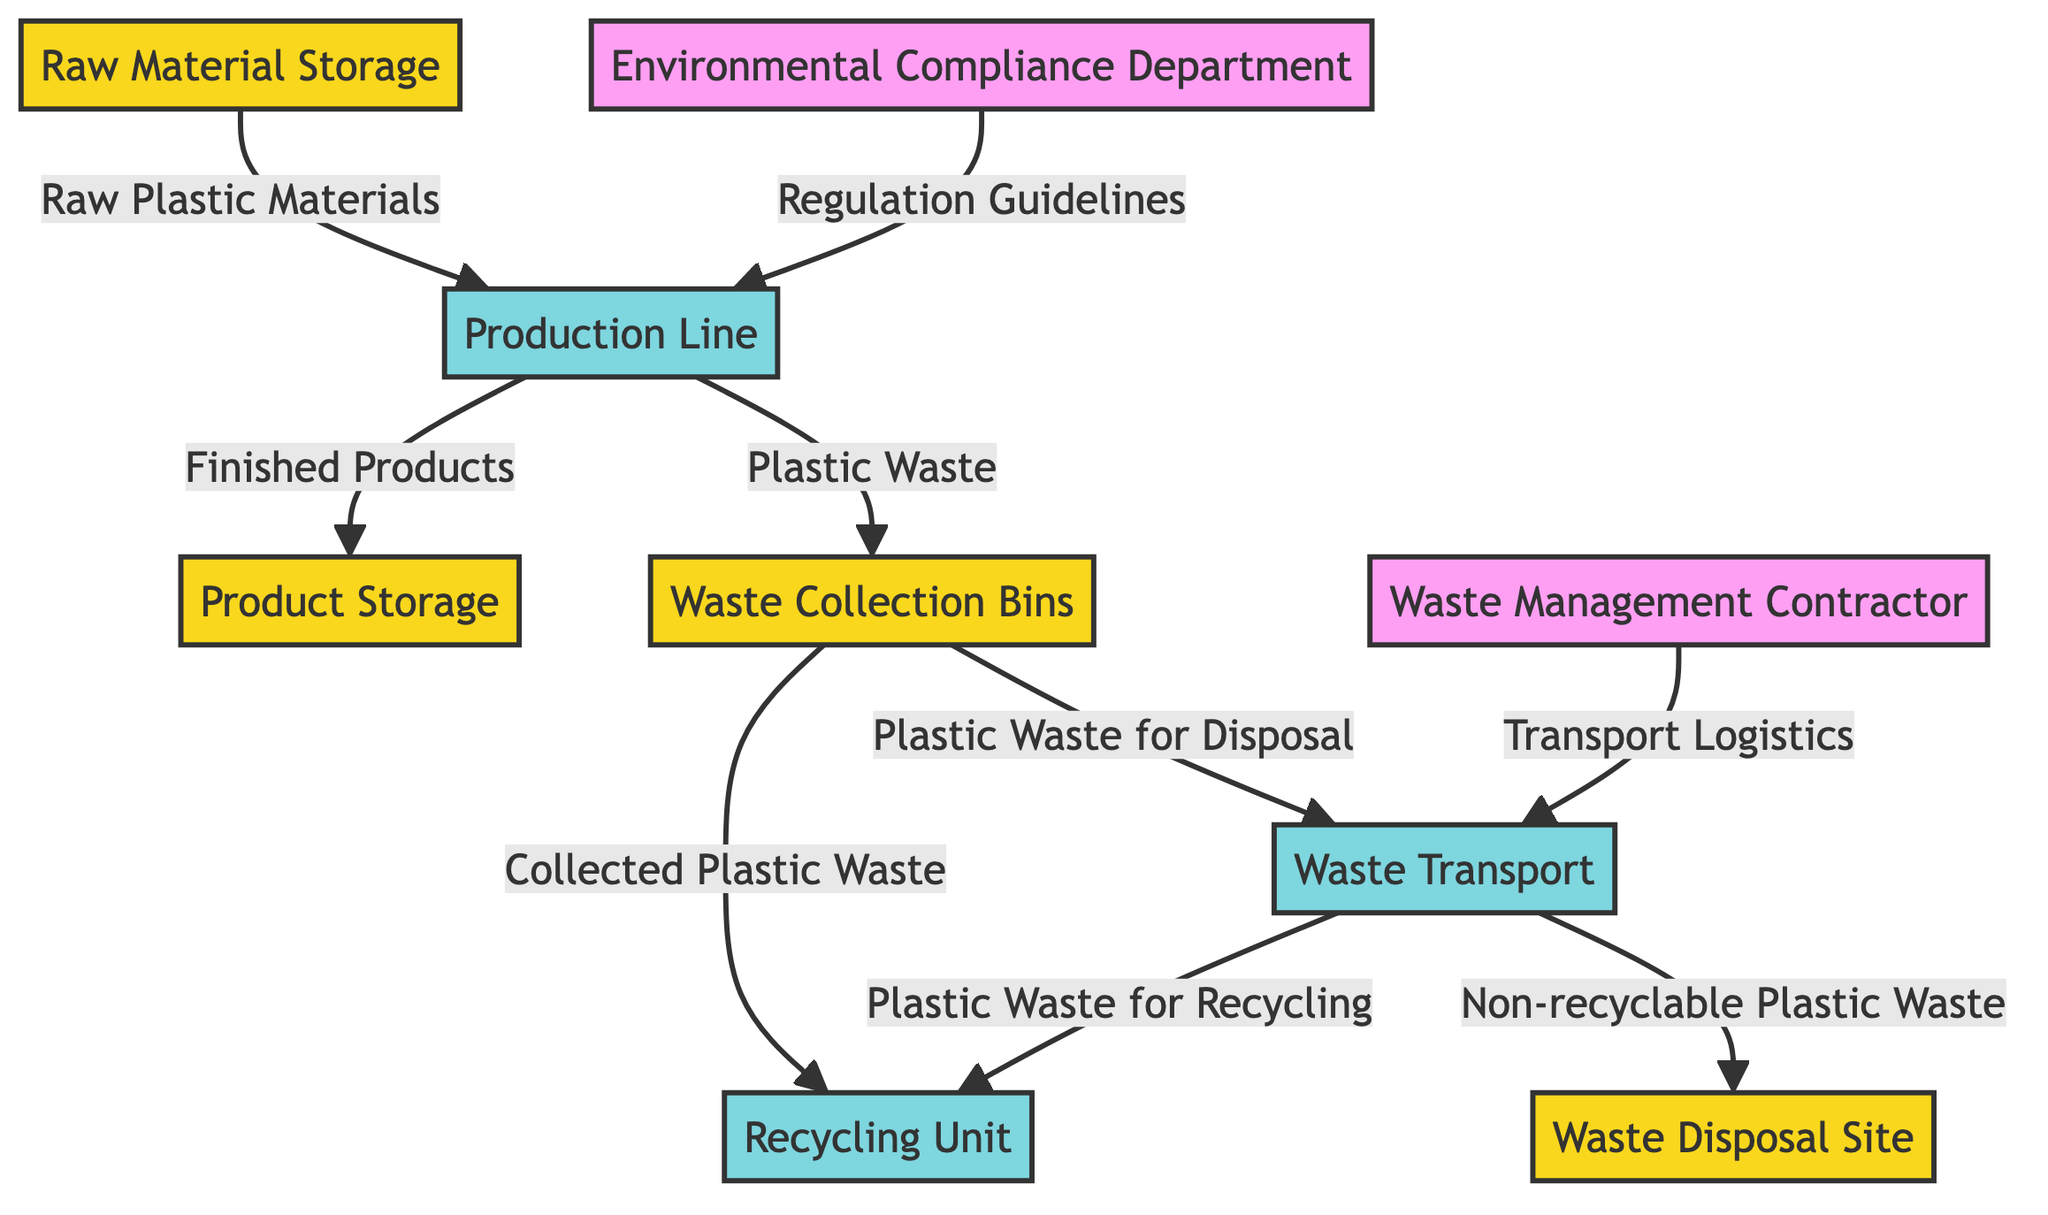What entity stores raw plastic materials? The diagram indicates "Raw Material Storage" as the entity storing raw plastic materials. It is labeled as a data store in the visual representation, signifying its role in the overall process.
Answer: Raw Material Storage How many processes are represented in the diagram? The diagram presents four distinct processes: Production Line, Recycling Unit, Waste Transport, and Waste Management Contractor. Each process is clearly identified as a process type, leading to multiple interactions with data stores and external entities.
Answer: Four What type of data flows from the Production Line to the Product Storage? The data flowing from the Production Line to the Product Storage is labeled as "Finished Products." This is mentioned in the diagram as the outcome of processing raw materials, categorized as finished goods prior to shipping.
Answer: Finished Products Which external entity is responsible for monitoring environmental compliance? The external entity focused on monitoring environmental compliance is labeled as "Environmental Compliance Department" in the diagram. Its role is visually distinct and essential for ensuring all processes adhere to regulations.
Answer: Environmental Compliance Department Where does non-recyclable plastic waste go? According to the diagram, non-recyclable plastic waste is directed to a "Waste Disposal Site." This endpoint indicates the final destination for waste that cannot undergo further recycling, ensuring proper disposal.
Answer: Waste Disposal Site What is the primary function of the Recycling Unit? The Recycling Unit's primary function, as depicted in the diagram, is to process collected plastic waste. It serves as a crucial point where recyclable waste is repurposed rather than disposed of, aiming to minimize environmental impact.
Answer: Processes collected plastic waste Which data flow indicates the transfer of plastic waste for recycling? The data flow labeled "Plastic Waste for Recycling" details the transfer occurring between Waste Transport and the Recycling Unit. This indicates the movement of waste that can be recycled rather than discarded.
Answer: Plastic Waste for Recycling How many external entities are involved in the diagram? The diagram identifies two external entities: Waste Management Contractor and Environmental Compliance Department. These entities play vital roles in the waste management process and regulatory compliance, respectively.
Answer: Two What is the role of the Waste Management Contractor? The Waste Management Contractor's role in the diagram is to provide "Transport Logistics," ensuring that waste is properly transported according to guidelines. This function is essential for maintaining an efficient waste management process.
Answer: Transport Logistics What is stored in the Waste Collection Bins? Waste Collection Bins are designated for storing "Plastic Waste" generated during the production process. This data store collects waste before it is processed or transported for disposal or recycling.
Answer: Plastic Waste 